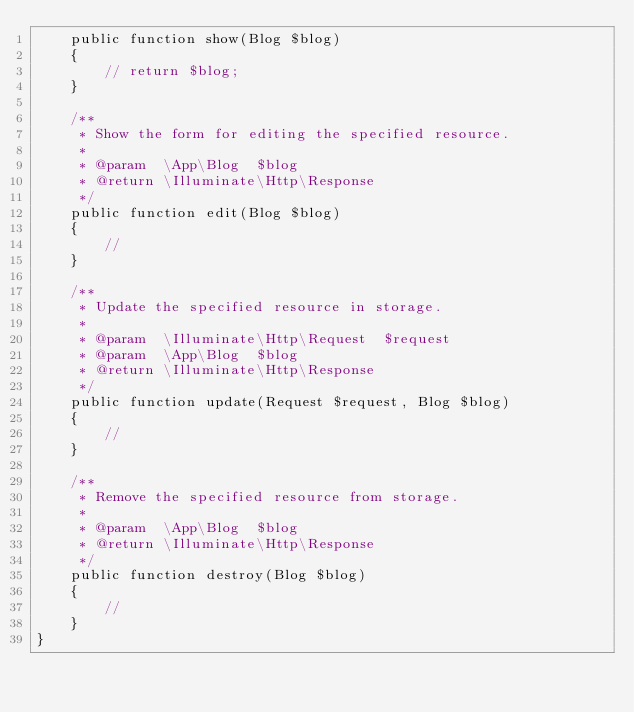Convert code to text. <code><loc_0><loc_0><loc_500><loc_500><_PHP_>    public function show(Blog $blog)
    {
        // return $blog;
    }

    /**
     * Show the form for editing the specified resource.
     *
     * @param  \App\Blog  $blog
     * @return \Illuminate\Http\Response
     */
    public function edit(Blog $blog)
    {
        //
    }

    /**
     * Update the specified resource in storage.
     *
     * @param  \Illuminate\Http\Request  $request
     * @param  \App\Blog  $blog
     * @return \Illuminate\Http\Response
     */
    public function update(Request $request, Blog $blog)
    {
        //
    }

    /**
     * Remove the specified resource from storage.
     *
     * @param  \App\Blog  $blog
     * @return \Illuminate\Http\Response
     */
    public function destroy(Blog $blog)
    {
        //
    }
}
</code> 